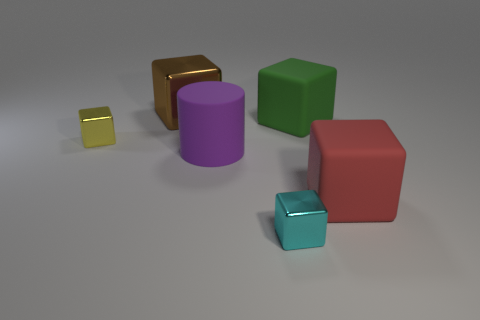Subtract 1 blocks. How many blocks are left? 4 Subtract all brown cubes. How many cubes are left? 4 Subtract all large green blocks. How many blocks are left? 4 Subtract all blue cubes. Subtract all gray cylinders. How many cubes are left? 5 Add 1 red cylinders. How many objects exist? 7 Subtract all cubes. How many objects are left? 1 Add 6 big red rubber things. How many big red rubber things are left? 7 Add 4 big brown shiny objects. How many big brown shiny objects exist? 5 Subtract 0 green cylinders. How many objects are left? 6 Subtract all purple things. Subtract all green matte cubes. How many objects are left? 4 